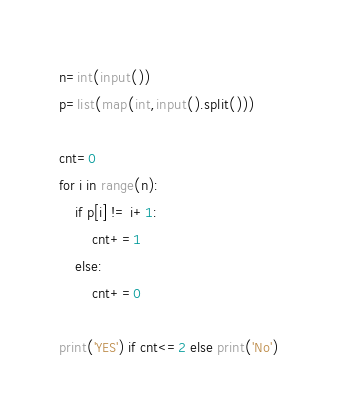Convert code to text. <code><loc_0><loc_0><loc_500><loc_500><_Python_>n=int(input())
p=list(map(int,input().split()))

cnt=0
for i in range(n):
    if p[i] != i+1:
        cnt+=1
    else:
        cnt+=0

print('YES') if cnt<=2 else print('No')</code> 